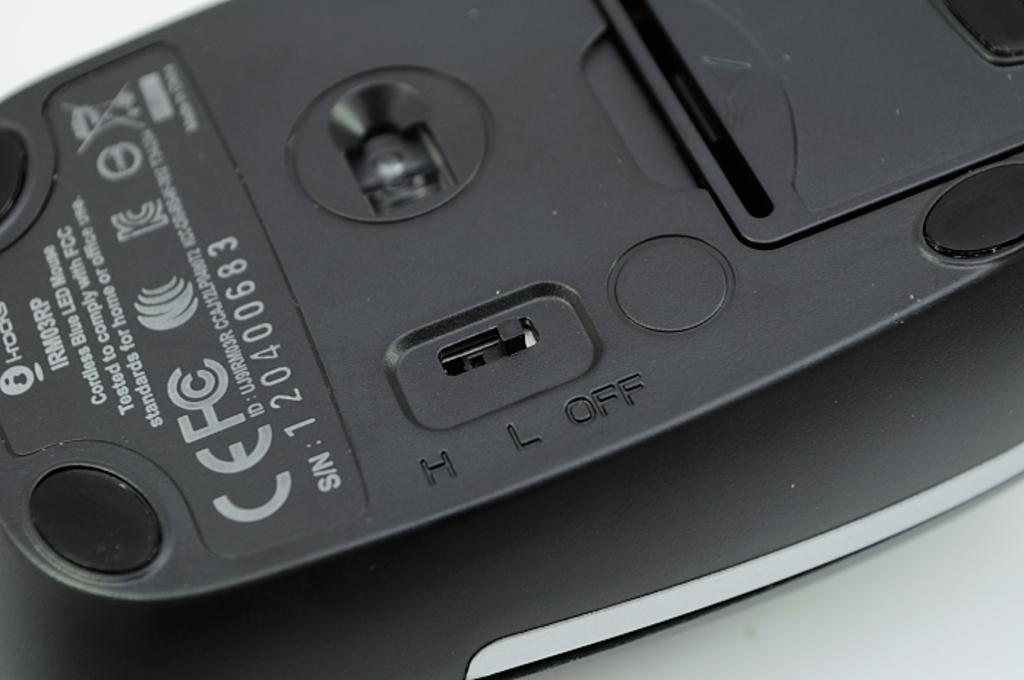<image>
Relay a brief, clear account of the picture shown. A black mouse with the model number IRM03RP. 